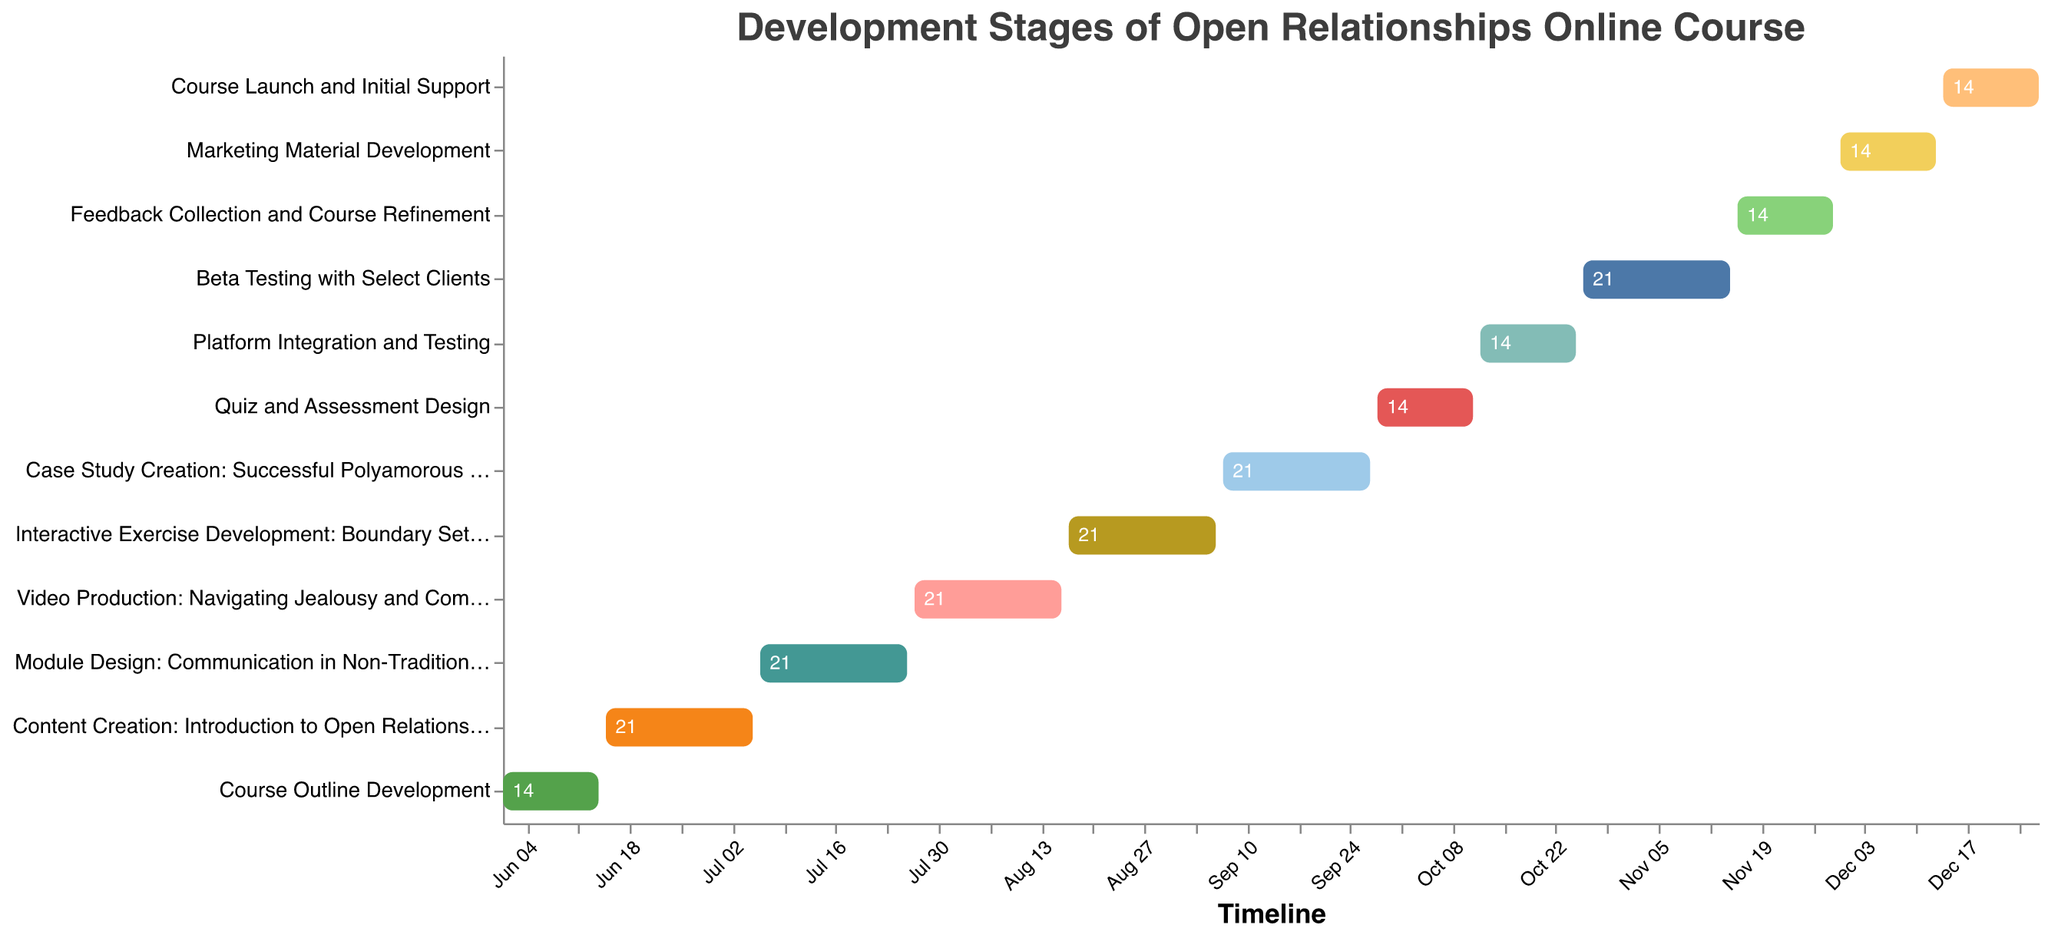What is the time span for the "Course Outline Development" task? The Gantt Chart indicates the start and end dates directly. For "Course Outline Development," it starts on June 1, 2023, and ends on June 14, 2023.
Answer: 14 days Which task has the longest duration? To identify the longest task, you need to compare the duration of all tasks listed. Several tasks share the longest duration of 21 days each.
Answer: Content Creation, Module Design, Video Production, Interactive Exercise Development, Case Study Creation, Beta Testing How many tasks have a duration of 14 days? Count the tasks that display a duration of 14 days on the Gantt Chart. The tasks are "Course Outline Development," "Quiz and Assessment Design," "Platform Integration and Testing," "Feedback Collection and Course Refinement," "Marketing Material Development," and "Course Launch and Initial Support."
Answer: 6 Which task directly follows "Interactive Exercise Development: Boundary Setting"? Examine the chronological order of the tasks listed. The task following "Interactive Exercise Development: Boundary Setting" is "Case Study Creation: Successful Polyamorous Relationships."
Answer: Case Study Creation: Successful Polyamorous Relationships During which month does "Beta Testing with Select Clients" start? Identify the start date for "Beta Testing with Select Clients." The Gantt Chart shows that it begins on October 26, 2023.
Answer: October Compare the durations of the "Platform Integration and Testing" and "Marketing Material Development" tasks. Which one is longer? Both tasks have a duration field, and you see that "Platform Integration and Testing" and "Marketing Material Development" each have a duration of 14 days.
Answer: They are equal What is the total time span from the start of "Course Outline Development" to the end of "Course Launch and Initial Support"? Calculate the total duration from the beginning of the first task to the end of the last. From June 1, 2023, to December 27, 2023.
Answer: 210 days How many tasks start in June? Count the tasks with start dates in June. These tasks are "Course Outline Development" and "Content Creation: Introduction to Open Relationships."
Answer: 2 Which is the shortest task in terms of duration? Identify the shortest duration shown in the Gantt Chart, which is shared by several tasks with a duration of 14 days.
Answer: Course Outline Development (among others) 